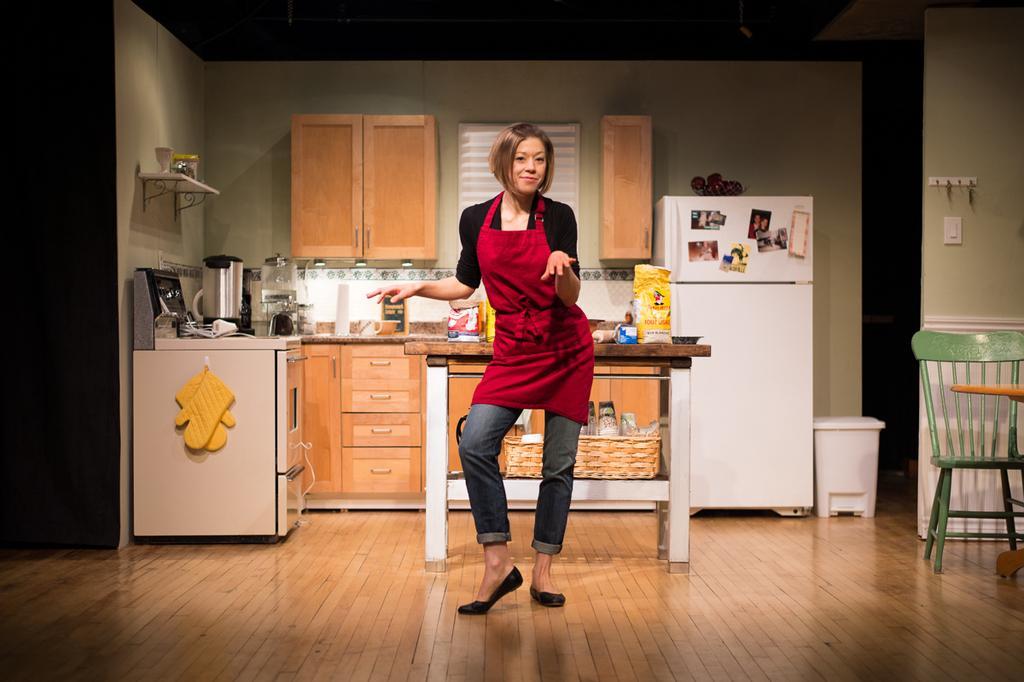How would you summarize this image in a sentence or two? In this image in the center there is one woman who is standing and in the background there is cupboard. On the cupboard there are some boxes, packets, bowls and some vessels and there is one fridge. On the fridge there are some photos, on the right side there is a chair dustbin and in the background there are some cupboards and a wall. At the bottom there is a wooden floor. 